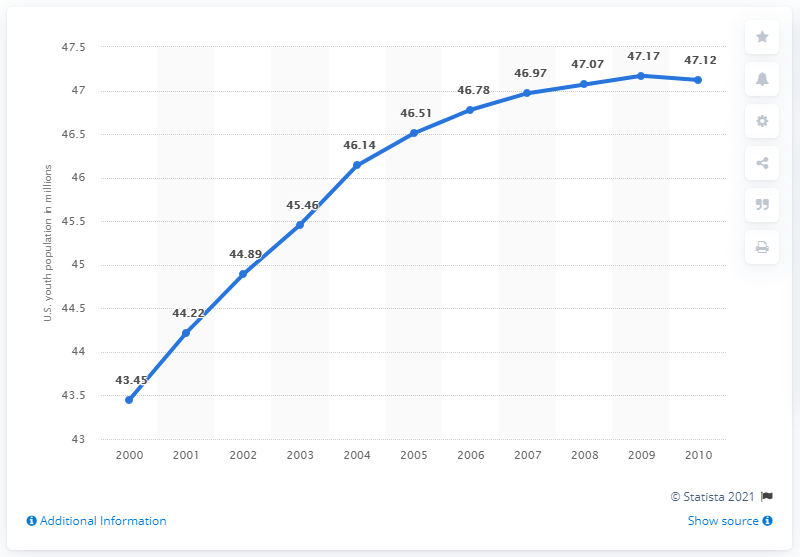Outline some significant characteristics in this image. In 2010, approximately 47.12% of the population in the United States between the ages of 14 and 24 lived. 